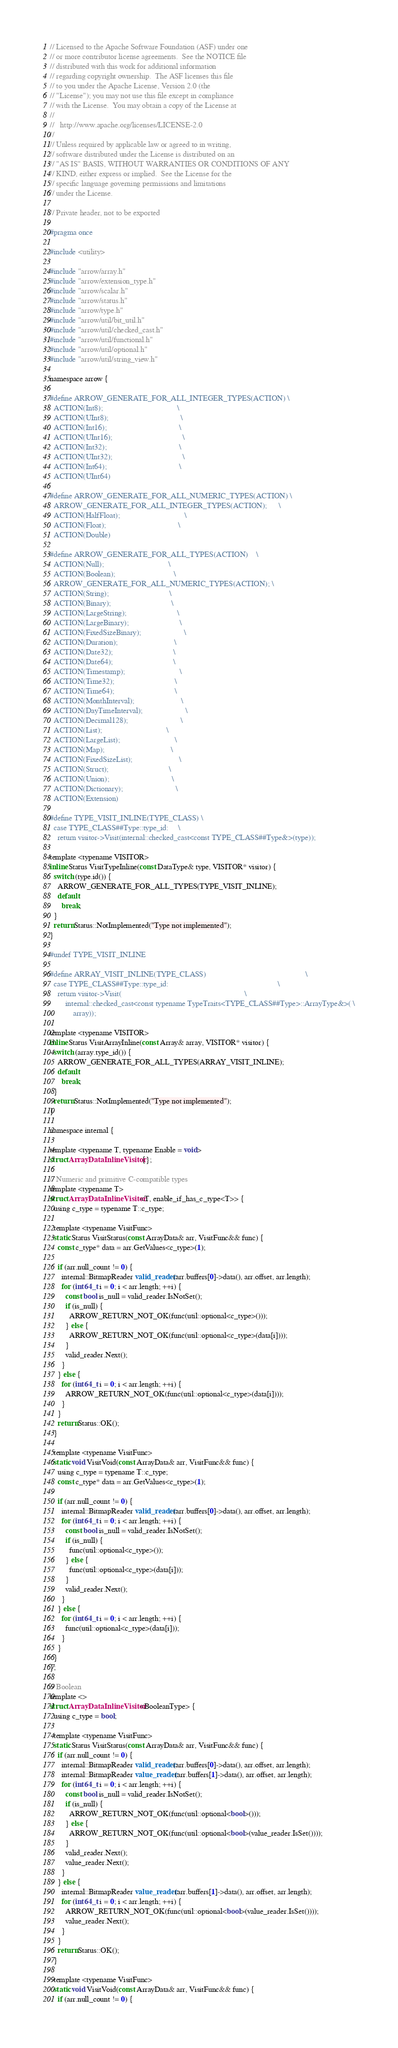Convert code to text. <code><loc_0><loc_0><loc_500><loc_500><_C_>// Licensed to the Apache Software Foundation (ASF) under one
// or more contributor license agreements.  See the NOTICE file
// distributed with this work for additional information
// regarding copyright ownership.  The ASF licenses this file
// to you under the Apache License, Version 2.0 (the
// "License"); you may not use this file except in compliance
// with the License.  You may obtain a copy of the License at
//
//   http://www.apache.org/licenses/LICENSE-2.0
//
// Unless required by applicable law or agreed to in writing,
// software distributed under the License is distributed on an
// "AS IS" BASIS, WITHOUT WARRANTIES OR CONDITIONS OF ANY
// KIND, either express or implied.  See the License for the
// specific language governing permissions and limitations
// under the License.

// Private header, not to be exported

#pragma once

#include <utility>

#include "arrow/array.h"
#include "arrow/extension_type.h"
#include "arrow/scalar.h"
#include "arrow/status.h"
#include "arrow/type.h"
#include "arrow/util/bit_util.h"
#include "arrow/util/checked_cast.h"
#include "arrow/util/functional.h"
#include "arrow/util/optional.h"
#include "arrow/util/string_view.h"

namespace arrow {

#define ARROW_GENERATE_FOR_ALL_INTEGER_TYPES(ACTION) \
  ACTION(Int8);                                      \
  ACTION(UInt8);                                     \
  ACTION(Int16);                                     \
  ACTION(UInt16);                                    \
  ACTION(Int32);                                     \
  ACTION(UInt32);                                    \
  ACTION(Int64);                                     \
  ACTION(UInt64)

#define ARROW_GENERATE_FOR_ALL_NUMERIC_TYPES(ACTION) \
  ARROW_GENERATE_FOR_ALL_INTEGER_TYPES(ACTION);      \
  ACTION(HalfFloat);                                 \
  ACTION(Float);                                     \
  ACTION(Double)

#define ARROW_GENERATE_FOR_ALL_TYPES(ACTION)    \
  ACTION(Null);                                 \
  ACTION(Boolean);                              \
  ARROW_GENERATE_FOR_ALL_NUMERIC_TYPES(ACTION); \
  ACTION(String);                               \
  ACTION(Binary);                               \
  ACTION(LargeString);                          \
  ACTION(LargeBinary);                          \
  ACTION(FixedSizeBinary);                      \
  ACTION(Duration);                             \
  ACTION(Date32);                               \
  ACTION(Date64);                               \
  ACTION(Timestamp);                            \
  ACTION(Time32);                               \
  ACTION(Time64);                               \
  ACTION(MonthInterval);                        \
  ACTION(DayTimeInterval);                      \
  ACTION(Decimal128);                           \
  ACTION(List);                                 \
  ACTION(LargeList);                            \
  ACTION(Map);                                  \
  ACTION(FixedSizeList);                        \
  ACTION(Struct);                               \
  ACTION(Union);                                \
  ACTION(Dictionary);                           \
  ACTION(Extension)

#define TYPE_VISIT_INLINE(TYPE_CLASS) \
  case TYPE_CLASS##Type::type_id:     \
    return visitor->Visit(internal::checked_cast<const TYPE_CLASS##Type&>(type));

template <typename VISITOR>
inline Status VisitTypeInline(const DataType& type, VISITOR* visitor) {
  switch (type.id()) {
    ARROW_GENERATE_FOR_ALL_TYPES(TYPE_VISIT_INLINE);
    default:
      break;
  }
  return Status::NotImplemented("Type not implemented");
}

#undef TYPE_VISIT_INLINE

#define ARRAY_VISIT_INLINE(TYPE_CLASS)                                                   \
  case TYPE_CLASS##Type::type_id:                                                        \
    return visitor->Visit(                                                               \
        internal::checked_cast<const typename TypeTraits<TYPE_CLASS##Type>::ArrayType&>( \
            array));

template <typename VISITOR>
inline Status VisitArrayInline(const Array& array, VISITOR* visitor) {
  switch (array.type_id()) {
    ARROW_GENERATE_FOR_ALL_TYPES(ARRAY_VISIT_INLINE);
    default:
      break;
  }
  return Status::NotImplemented("Type not implemented");
}

namespace internal {

template <typename T, typename Enable = void>
struct ArrayDataInlineVisitor {};

// Numeric and primitive C-compatible types
template <typename T>
struct ArrayDataInlineVisitor<T, enable_if_has_c_type<T>> {
  using c_type = typename T::c_type;

  template <typename VisitFunc>
  static Status VisitStatus(const ArrayData& arr, VisitFunc&& func) {
    const c_type* data = arr.GetValues<c_type>(1);

    if (arr.null_count != 0) {
      internal::BitmapReader valid_reader(arr.buffers[0]->data(), arr.offset, arr.length);
      for (int64_t i = 0; i < arr.length; ++i) {
        const bool is_null = valid_reader.IsNotSet();
        if (is_null) {
          ARROW_RETURN_NOT_OK(func(util::optional<c_type>()));
        } else {
          ARROW_RETURN_NOT_OK(func(util::optional<c_type>(data[i])));
        }
        valid_reader.Next();
      }
    } else {
      for (int64_t i = 0; i < arr.length; ++i) {
        ARROW_RETURN_NOT_OK(func(util::optional<c_type>(data[i])));
      }
    }
    return Status::OK();
  }

  template <typename VisitFunc>
  static void VisitVoid(const ArrayData& arr, VisitFunc&& func) {
    using c_type = typename T::c_type;
    const c_type* data = arr.GetValues<c_type>(1);

    if (arr.null_count != 0) {
      internal::BitmapReader valid_reader(arr.buffers[0]->data(), arr.offset, arr.length);
      for (int64_t i = 0; i < arr.length; ++i) {
        const bool is_null = valid_reader.IsNotSet();
        if (is_null) {
          func(util::optional<c_type>());
        } else {
          func(util::optional<c_type>(data[i]));
        }
        valid_reader.Next();
      }
    } else {
      for (int64_t i = 0; i < arr.length; ++i) {
        func(util::optional<c_type>(data[i]));
      }
    }
  }
};

// Boolean
template <>
struct ArrayDataInlineVisitor<BooleanType> {
  using c_type = bool;

  template <typename VisitFunc>
  static Status VisitStatus(const ArrayData& arr, VisitFunc&& func) {
    if (arr.null_count != 0) {
      internal::BitmapReader valid_reader(arr.buffers[0]->data(), arr.offset, arr.length);
      internal::BitmapReader value_reader(arr.buffers[1]->data(), arr.offset, arr.length);
      for (int64_t i = 0; i < arr.length; ++i) {
        const bool is_null = valid_reader.IsNotSet();
        if (is_null) {
          ARROW_RETURN_NOT_OK(func(util::optional<bool>()));
        } else {
          ARROW_RETURN_NOT_OK(func(util::optional<bool>(value_reader.IsSet())));
        }
        valid_reader.Next();
        value_reader.Next();
      }
    } else {
      internal::BitmapReader value_reader(arr.buffers[1]->data(), arr.offset, arr.length);
      for (int64_t i = 0; i < arr.length; ++i) {
        ARROW_RETURN_NOT_OK(func(util::optional<bool>(value_reader.IsSet())));
        value_reader.Next();
      }
    }
    return Status::OK();
  }

  template <typename VisitFunc>
  static void VisitVoid(const ArrayData& arr, VisitFunc&& func) {
    if (arr.null_count != 0) {</code> 